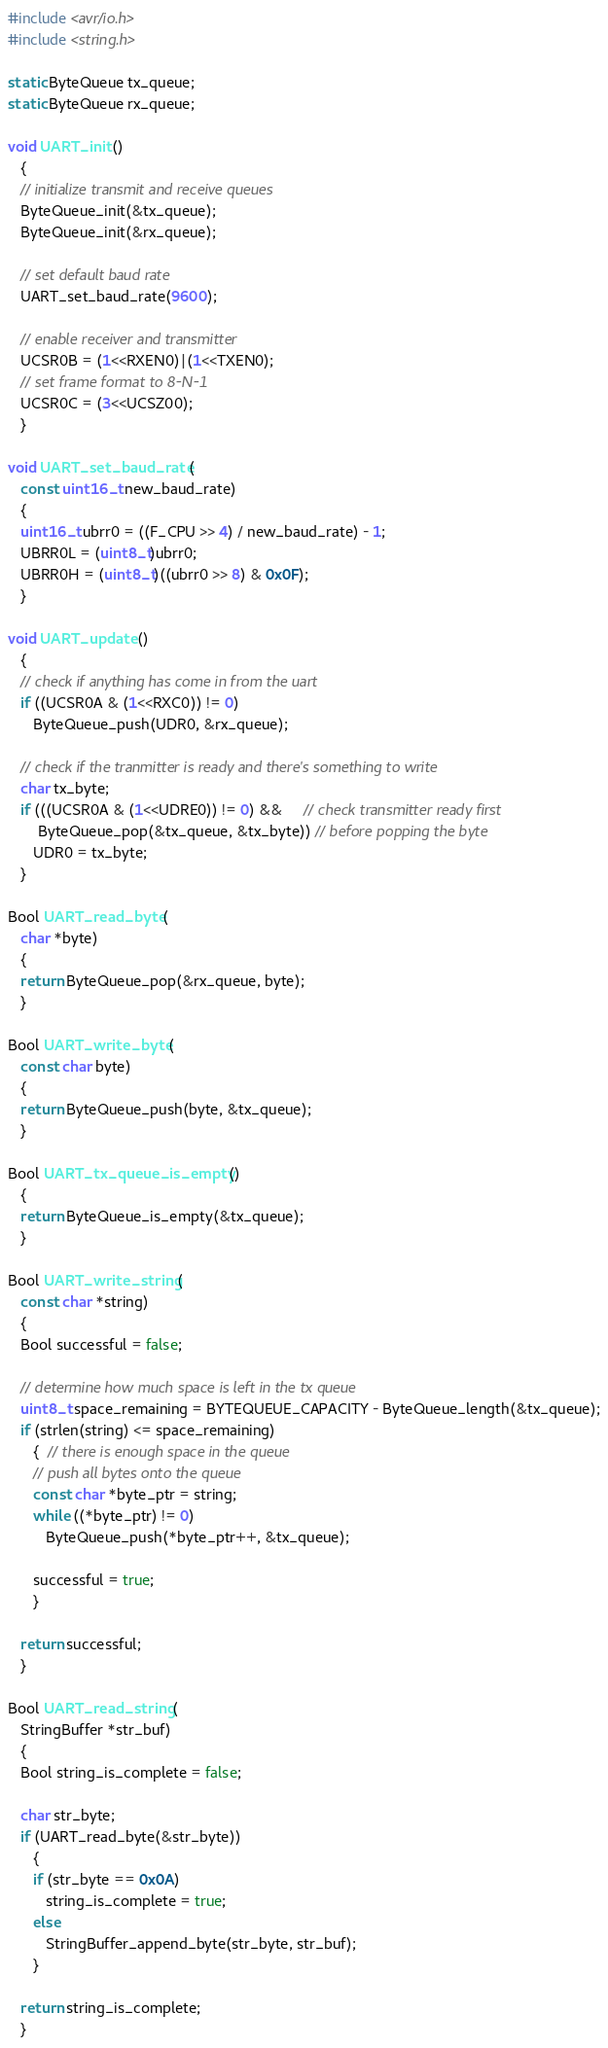<code> <loc_0><loc_0><loc_500><loc_500><_C_>#include <avr/io.h>
#include <string.h>

static ByteQueue tx_queue;
static ByteQueue rx_queue;

void UART_init ()
   {
   // initialize transmit and receive queues
   ByteQueue_init(&tx_queue);
   ByteQueue_init(&rx_queue);

   // set default baud rate
   UART_set_baud_rate(9600);

   // enable receiver and transmitter
   UCSR0B = (1<<RXEN0)|(1<<TXEN0);
   // set frame format to 8-N-1
   UCSR0C = (3<<UCSZ00);
   }

void UART_set_baud_rate (
   const uint16_t new_baud_rate)
   {
   uint16_t ubrr0 = ((F_CPU >> 4) / new_baud_rate) - 1;
   UBRR0L = (uint8_t)ubrr0;
   UBRR0H = (uint8_t)((ubrr0 >> 8) & 0x0F);
   }

void UART_update ()
   {
   // check if anything has come in from the uart
   if ((UCSR0A & (1<<RXC0)) != 0)
      ByteQueue_push(UDR0, &rx_queue);

   // check if the tranmitter is ready and there's something to write 
   char tx_byte;
   if (((UCSR0A & (1<<UDRE0)) != 0) &&     // check transmitter ready first
       ByteQueue_pop(&tx_queue, &tx_byte)) // before popping the byte
      UDR0 = tx_byte;
   }

Bool UART_read_byte (
   char *byte)
   {
   return ByteQueue_pop(&rx_queue, byte);
   }

Bool UART_write_byte (
   const char byte)
   {
   return ByteQueue_push(byte, &tx_queue);
   }

Bool UART_tx_queue_is_empty ()
   {
   return ByteQueue_is_empty(&tx_queue);
   }

Bool UART_write_string (
   const char *string)
   {
   Bool successful = false;

   // determine how much space is left in the tx queue
   uint8_t space_remaining = BYTEQUEUE_CAPACITY - ByteQueue_length(&tx_queue);
   if (strlen(string) <= space_remaining)
      {  // there is enough space in the queue
      // push all bytes onto the queue
      const char *byte_ptr = string;
      while ((*byte_ptr) != 0)
         ByteQueue_push(*byte_ptr++, &tx_queue);

      successful = true;
      }

   return successful;
   }

Bool UART_read_string (
   StringBuffer *str_buf)
   {
   Bool string_is_complete = false;

   char str_byte;
   if (UART_read_byte(&str_byte))
      {
      if (str_byte == 0x0A)
         string_is_complete = true;
      else
         StringBuffer_append_byte(str_byte, str_buf);
      }

   return string_is_complete;
   }

</code> 